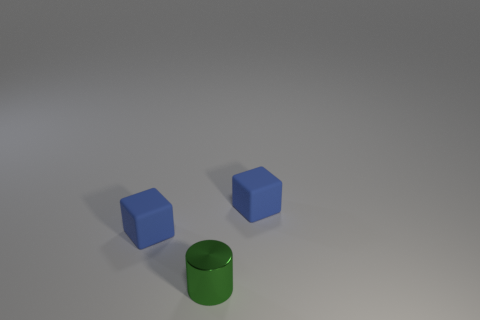Is there anything else that is the same shape as the tiny green shiny thing?
Provide a short and direct response. No. There is a green metal thing that is in front of the small matte cube right of the green metal cylinder; how big is it?
Provide a short and direct response. Small. Is the number of tiny green cylinders greater than the number of blue shiny objects?
Your response must be concise. Yes. How many other metal objects are the same size as the metal object?
Make the answer very short. 0. Are there fewer small cubes behind the small green cylinder than small things?
Offer a very short reply. Yes. Are there any tiny cubes that have the same material as the green thing?
Provide a short and direct response. No. Is there a tiny blue rubber thing left of the tiny blue rubber object to the right of the blue matte cube that is on the left side of the small green cylinder?
Your answer should be very brief. Yes. How many other things are there of the same shape as the green metallic object?
Offer a very short reply. 0. There is a small matte thing that is to the right of the cube to the left of the blue rubber object that is to the right of the tiny cylinder; what is its color?
Provide a succinct answer. Blue. How many purple things are there?
Provide a short and direct response. 0. 